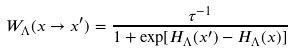<formula> <loc_0><loc_0><loc_500><loc_500>W _ { \Lambda } ( x \to x ^ { \prime } ) = \frac { \tau ^ { - 1 } } { 1 + \exp [ H _ { \Lambda } ( x ^ { \prime } ) - H _ { \Lambda } ( x ) ] }</formula> 